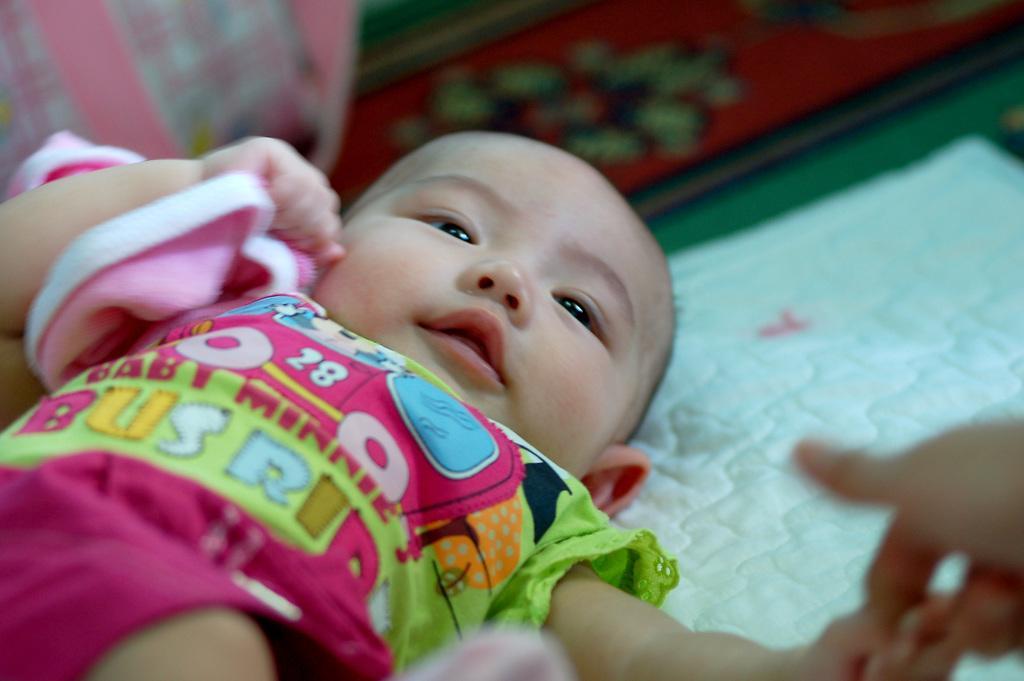Can you describe this image briefly? In this image I can see the baby lying on the green color cloth and the baby is wearing pink, blue and green color dress and I can see the blurred background. 